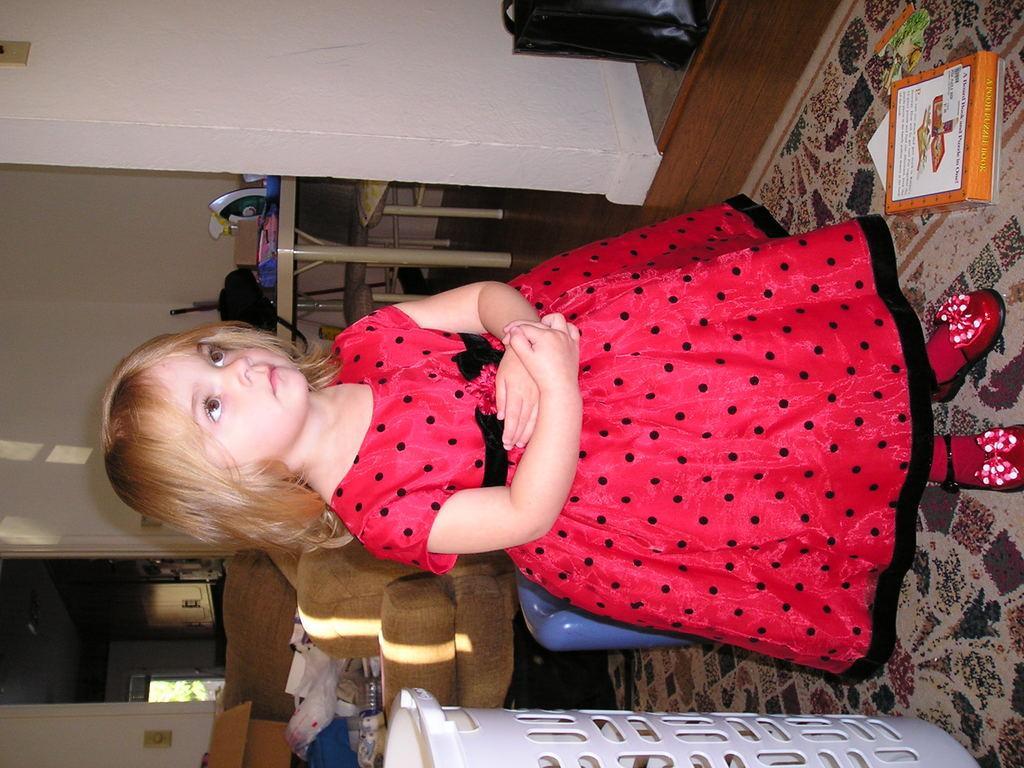Please provide a concise description of this image. In the center of the image, we can see a girl standing and in the background, there are some objects on the table and we can see some other objects on the couch and we can see a basket and there is a wall. On the right, we can see a bag. At the bottom, there is carpet and we can see a box. 